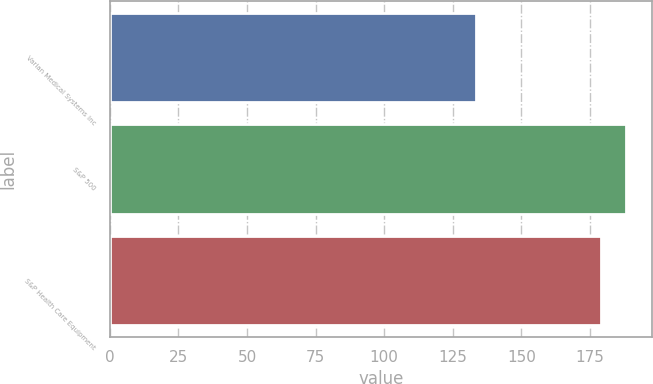Convert chart to OTSL. <chart><loc_0><loc_0><loc_500><loc_500><bar_chart><fcel>Varian Medical Systems Inc<fcel>S&P 500<fcel>S&P Health Care Equipment<nl><fcel>133.32<fcel>188.18<fcel>178.85<nl></chart> 